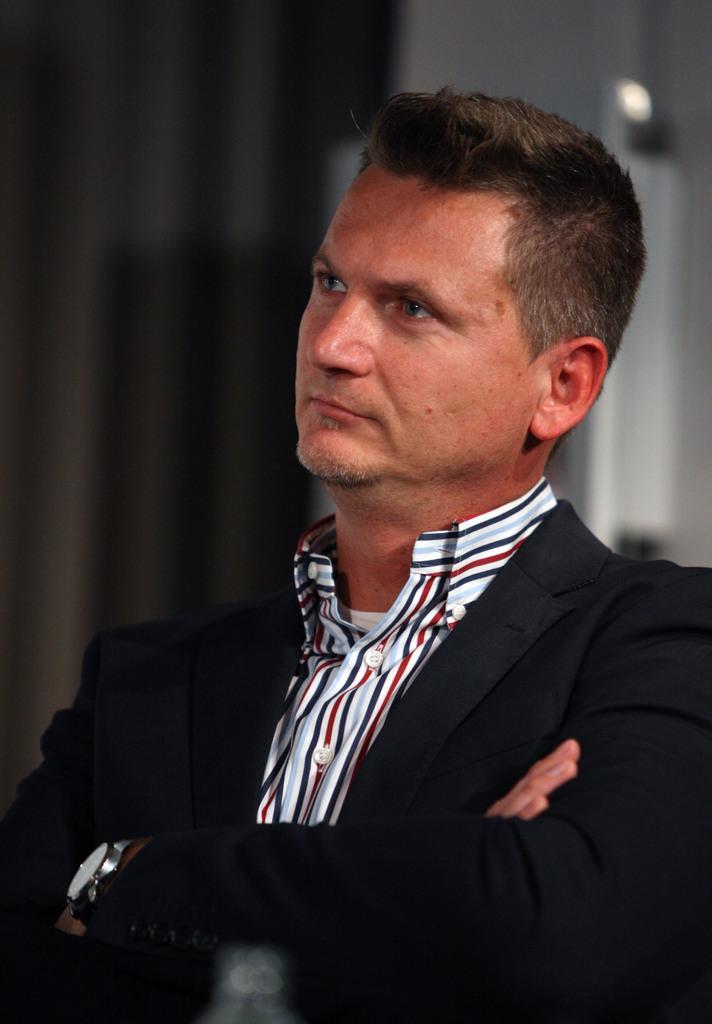Please provide a concise description of this image. This person wore a suit and looking left side of the image. Background it is blur. 